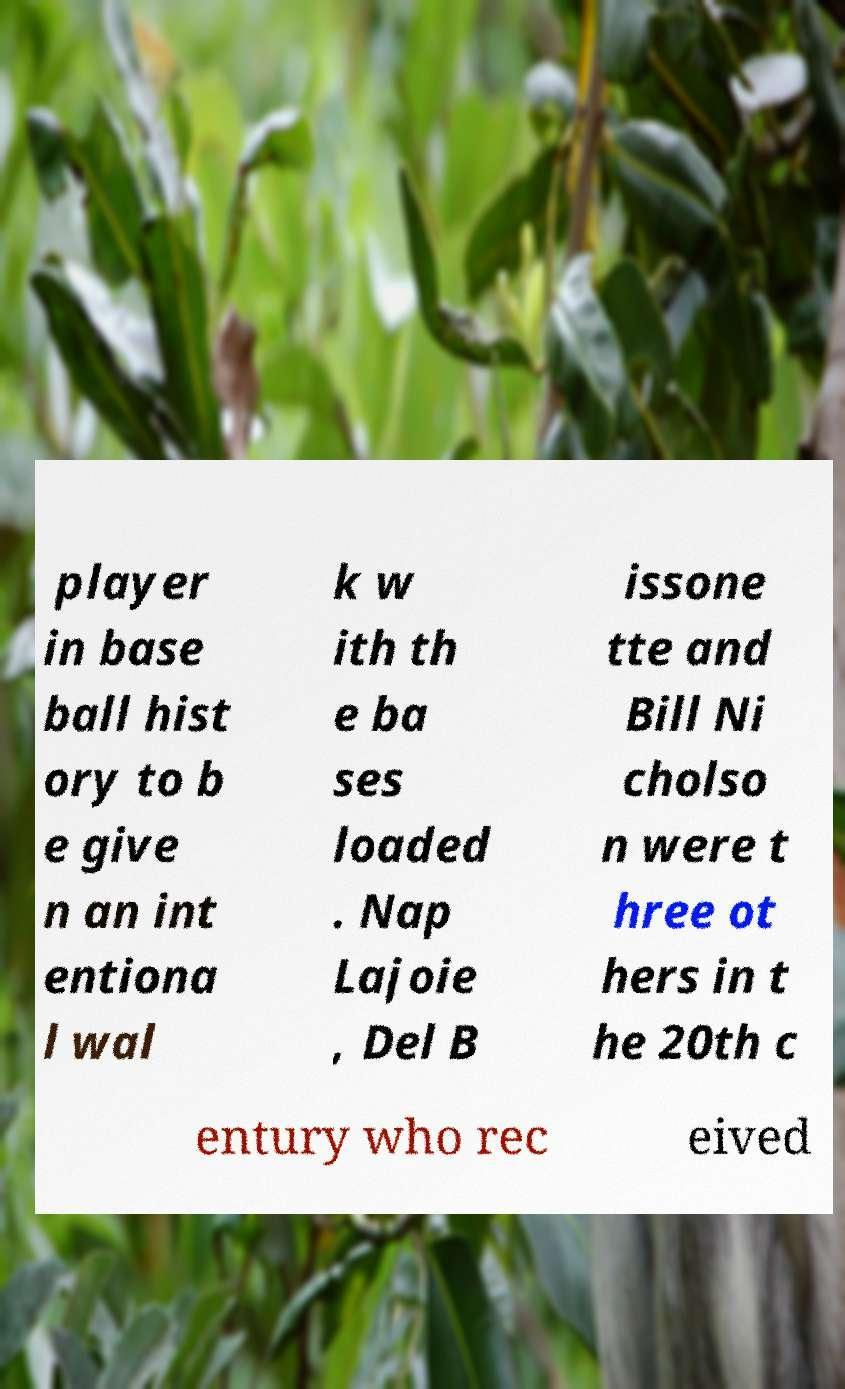For documentation purposes, I need the text within this image transcribed. Could you provide that? player in base ball hist ory to b e give n an int entiona l wal k w ith th e ba ses loaded . Nap Lajoie , Del B issone tte and Bill Ni cholso n were t hree ot hers in t he 20th c entury who rec eived 